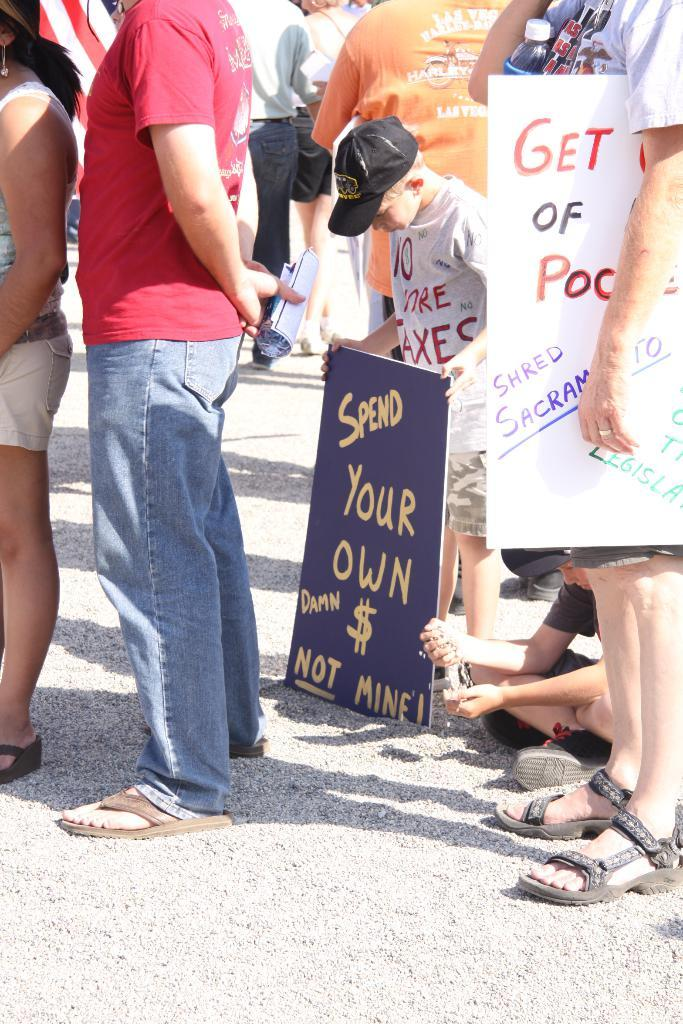How many people are in the image? There are multiple persons in the image. What are some of the persons holding? Some of the persons are holding boards. Can you describe the position of the person on the right side? One person is sitting on the right side. What are the other persons doing in the image? The rest of the persons are standing. What type of cap can be seen on the person's head in the image? There is no cap visible on any person's head in the image. What kind of border is surrounding the image? The provided facts do not mention any border surrounding the image. 